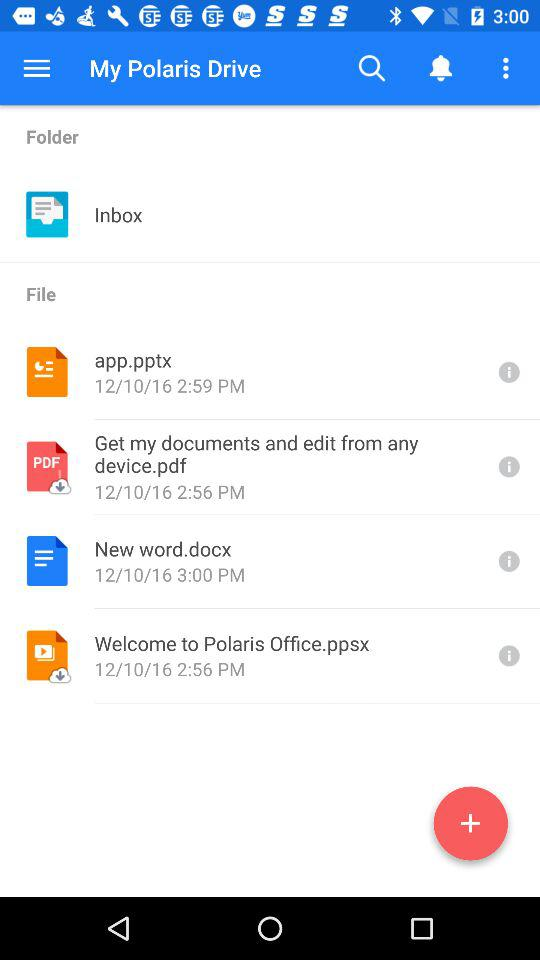How many of the items are pdfs?
Answer the question using a single word or phrase. 1 